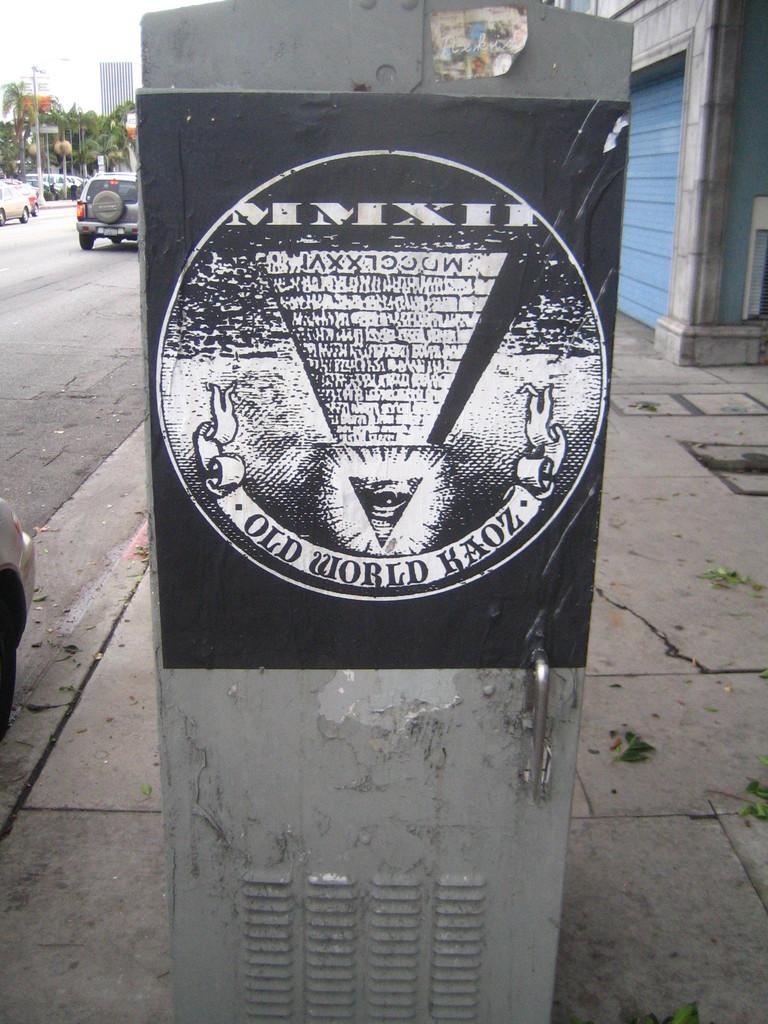What is old?
Provide a succinct answer. World kaoz. 